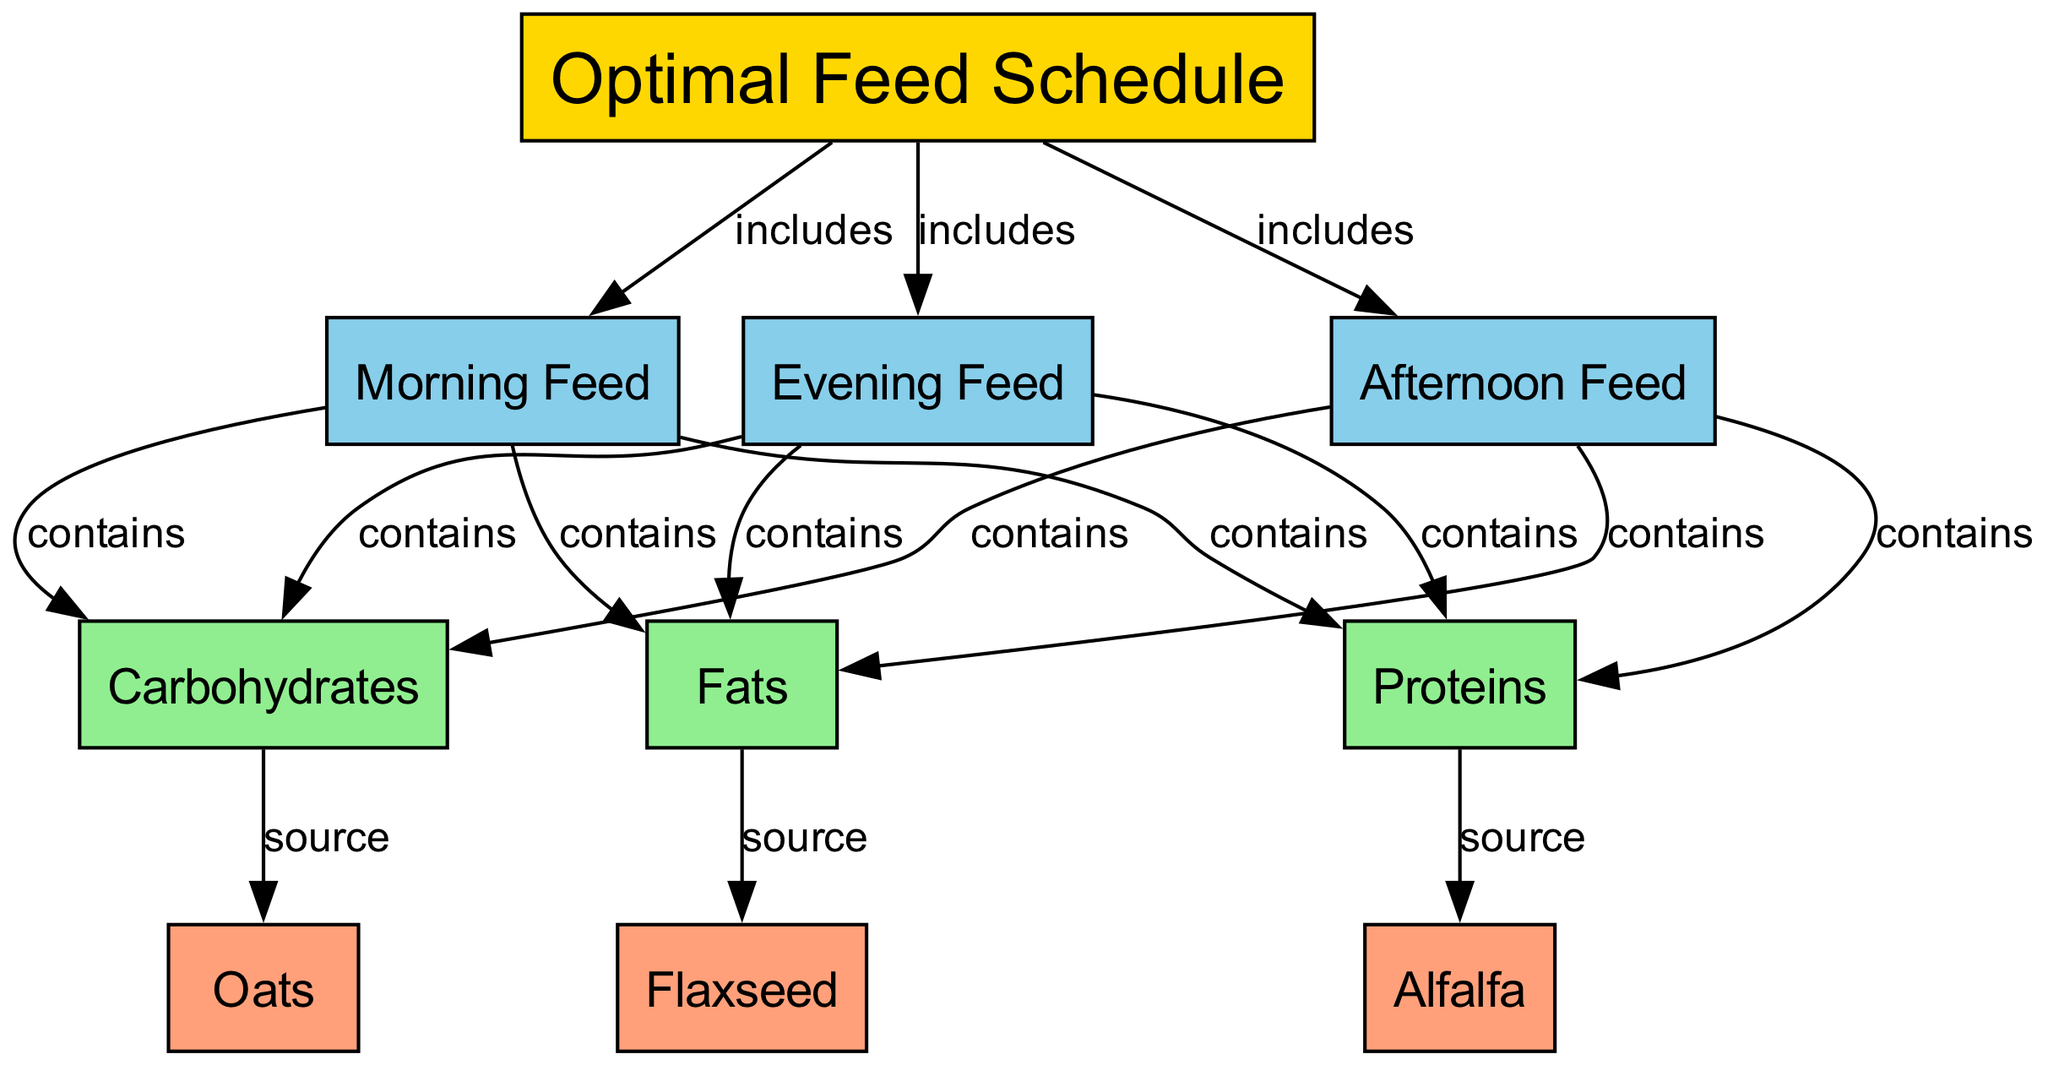What are the three feed times depicted in the diagram? The diagram lists Morning Feed, Afternoon Feed, and Evening Feed as the different times when the horse is fed.
Answer: Morning Feed, Afternoon Feed, Evening Feed How many nutrients are included in the feed schedule? The diagram indicates that there are three nutrients: Carbohydrates, Proteins, and Fats.
Answer: Three Which food item is a source of carbohydrates? According to the diagram, Oats is the food item that serves as a source of carbohydrates.
Answer: Oats What nutrient is Alfalfa associated with in the feed schedule? The diagram shows that Alfalfa is associated with Proteins, indicated by the connection from Proteins to Alfalfa in the diagram.
Answer: Proteins What is the connection type between Evening Feed and the nutrients? The connection type between Evening Feed and the nutrients is "contains," as indicated by the labeled edges in the diagram.
Answer: contains How many total edges are present in the diagram? The diagram shows a total of twelve edges connecting the nodes (time periods, nutrients, and food items). Counted through inspection, this total reflects all relationships outlined between the different elements.
Answer: Twelve Which food item provides fats? The diagram specifies that Flaxseed is the food item that provides Fats, indicated by its connection to the nutrient.
Answer: Flaxseed Are there any food items associated with the Morning Feed? Yes, the diagram shows that Morning Feed contains Carbohydrates, Proteins, and Fats, with their respective food items Oats, Alfalfa, and Flaxseed.
Answer: Yes What is the nutrient source for Proteins according to the feed schedule? The nutrient source for Proteins in the feed schedule is Alfalfa, as reflected in the relationship pathways of the diagram.
Answer: Alfalfa 